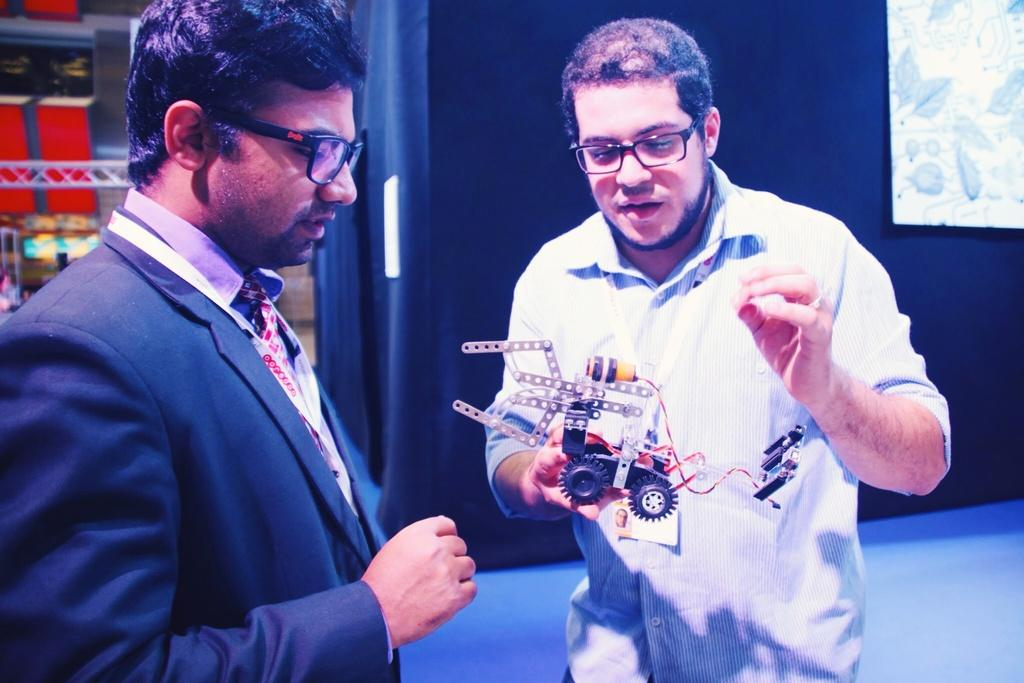How many people are in the image? There are two people standing in the image. What is one person holding? One person is holding a motor car. What can be seen behind the people in the image? There is a wall visible in the image. What is on the wall? There is a board on the wall. What type of soda is being advertised on the board on the wall? There is no soda or advertisement visible on the board in the image. How many arches can be seen in the image? There are no arches present in the image. 